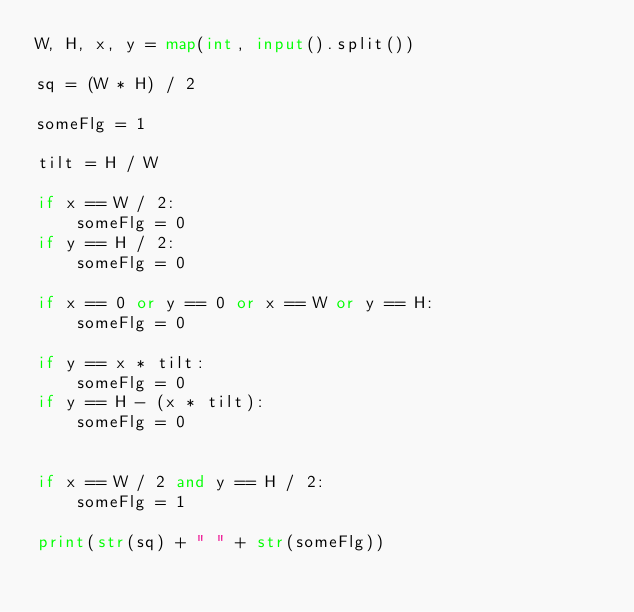<code> <loc_0><loc_0><loc_500><loc_500><_Python_>W, H, x, y = map(int, input().split())

sq = (W * H) / 2

someFlg = 1

tilt = H / W

if x == W / 2:
    someFlg = 0
if y == H / 2:
    someFlg = 0

if x == 0 or y == 0 or x == W or y == H:
    someFlg = 0

if y == x * tilt:
    someFlg = 0
if y == H - (x * tilt):
    someFlg = 0


if x == W / 2 and y == H / 2:
    someFlg = 1

print(str(sq) + " " + str(someFlg))</code> 